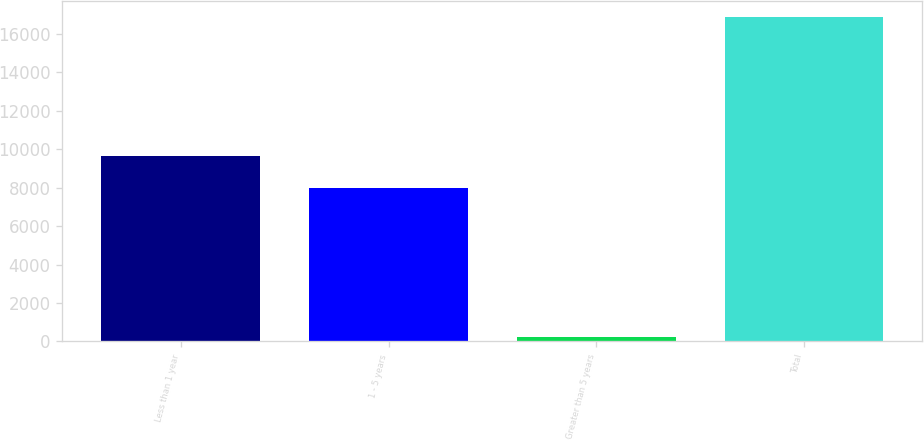<chart> <loc_0><loc_0><loc_500><loc_500><bar_chart><fcel>Less than 1 year<fcel>1 - 5 years<fcel>Greater than 5 years<fcel>Total<nl><fcel>9647.5<fcel>7986<fcel>233<fcel>16848<nl></chart> 